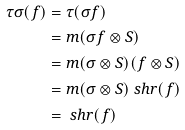Convert formula to latex. <formula><loc_0><loc_0><loc_500><loc_500>\tau \sigma ( f ) & = \tau ( \sigma f ) \\ & = m ( \sigma f \otimes S ) \\ & = m ( \sigma \otimes S ) ( f \otimes S ) \\ & = m ( \sigma \otimes S ) \ s h r ( f ) \\ & = \ s h r ( f )</formula> 